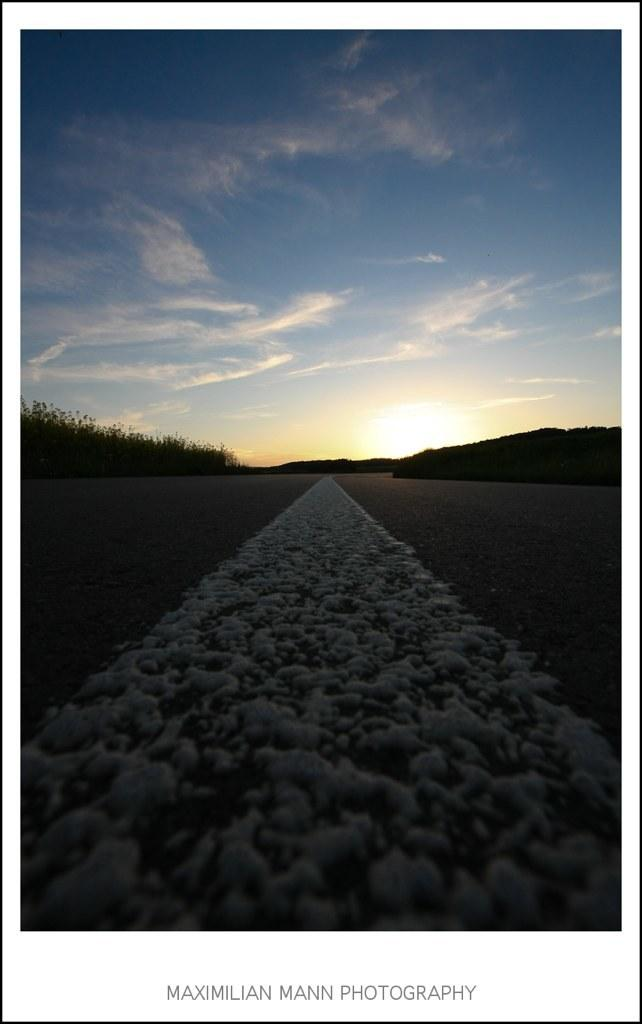What type of pathway is visible in the image? There is a road in the image. What natural elements can be seen in the image? There are trees and hills visible in the image. What celestial body is visible in the image? The sun is visible in the image. What part of the natural environment is visible in the image? The sky is visible in the image, and clouds are present in the sky. Is there any text or writing in the image? Yes, there is edited text in the image. What type of brass instrument is being played by the duck in the image? There is no brass instrument or duck present in the image. How much honey is being consumed by the trees in the image? There is no honey or consumption of honey by trees in the image. 